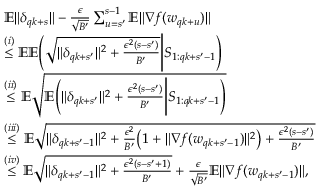Convert formula to latex. <formula><loc_0><loc_0><loc_500><loc_500>\begin{array} { r l } & { \mathbb { E } \| \delta _ { q k + s } \| - \frac { \epsilon } { \sqrt { B ^ { \prime } } } \sum _ { u = s ^ { \prime } } ^ { s - 1 } \mathbb { E } \| \nabla f ( w _ { q k + u } ) \| } \\ & { \overset { ( i ) } { \leq } \mathbb { E } \mathbb { E } \left ( \sqrt { \| \delta _ { q k + s ^ { \prime } } \| ^ { 2 } + \frac { \epsilon ^ { 2 } ( s - s ^ { \prime } ) } { B ^ { \prime } } } \left | S _ { 1 \colon q k + s ^ { \prime } - 1 } \right ) } \\ & { \overset { ( i i ) } { \leq } \mathbb { E } \sqrt { \mathbb { E } \left ( \| \delta _ { q k + s ^ { \prime } } \| ^ { 2 } + \frac { \epsilon ^ { 2 } ( s - s ^ { \prime } ) } { B ^ { \prime } } \right | S _ { 1 \colon q k + s ^ { \prime } - 1 } \right ) } } \\ & { \overset { ( i i i ) } { \leq } \mathbb { E } \sqrt { \| \delta _ { q k + s ^ { \prime } - 1 } \| ^ { 2 } + \frac { \epsilon ^ { 2 } } { B ^ { \prime } } \left ( 1 + \| \nabla f ( w _ { q k + s ^ { \prime } - 1 } ) \| ^ { 2 } \right ) + \frac { \epsilon ^ { 2 } ( s - s ^ { \prime } ) } { B ^ { \prime } } } } \\ & { \overset { ( i v ) } { \leq } \mathbb { E } \sqrt { \| \delta _ { q k + s ^ { \prime } - 1 } \| ^ { 2 } + \frac { \epsilon ^ { 2 } ( s - s ^ { \prime } + 1 ) } { B ^ { \prime } } } + \frac { \epsilon } { \sqrt { B ^ { \prime } } } \mathbb { E } \| \nabla f ( w _ { q k + s ^ { \prime } - 1 } ) \| , } \end{array}</formula> 